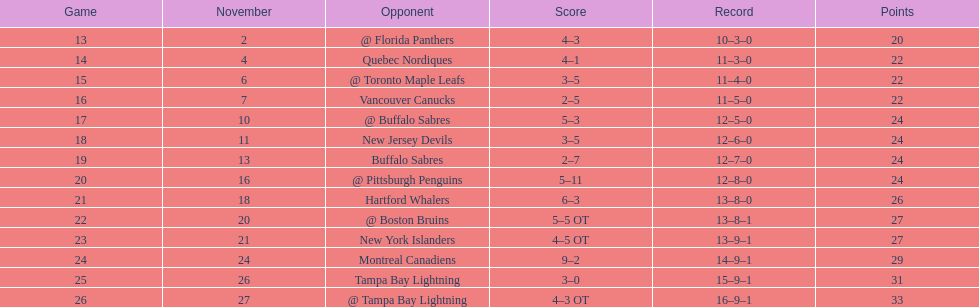Which additional team had the nearest number of victories? New York Islanders. 